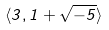<formula> <loc_0><loc_0><loc_500><loc_500>\langle 3 , 1 + \sqrt { - 5 } \rangle</formula> 